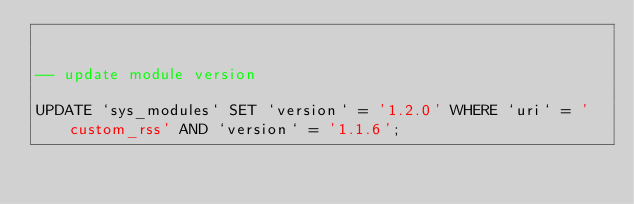<code> <loc_0><loc_0><loc_500><loc_500><_SQL_>

-- update module version

UPDATE `sys_modules` SET `version` = '1.2.0' WHERE `uri` = 'custom_rss' AND `version` = '1.1.6';

</code> 